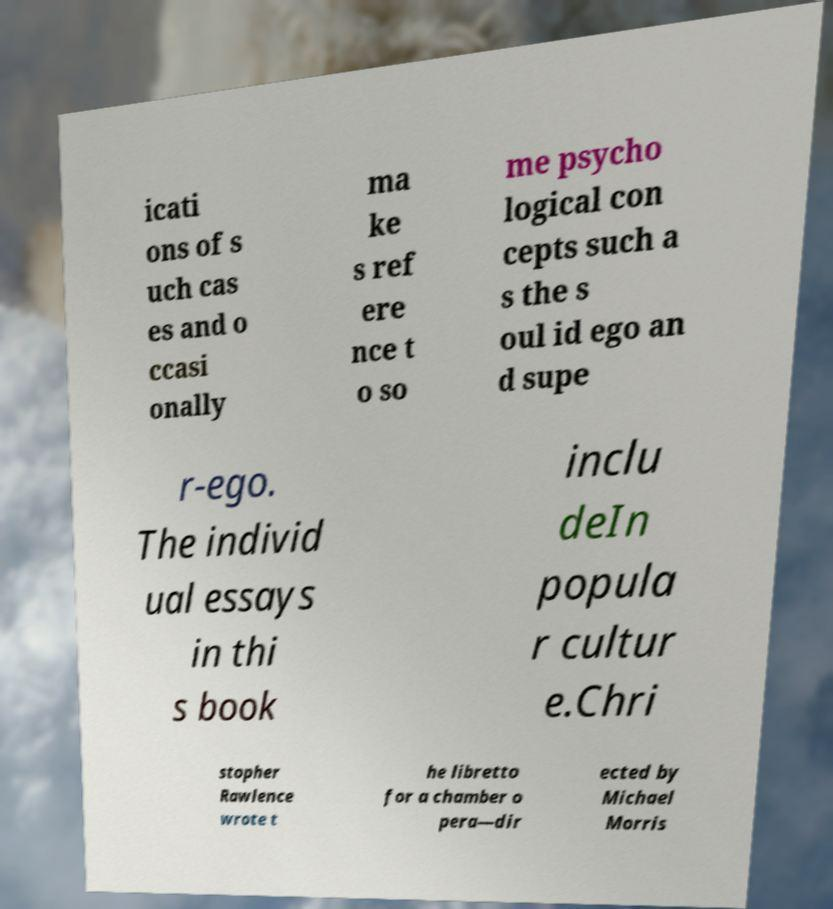Please read and relay the text visible in this image. What does it say? icati ons of s uch cas es and o ccasi onally ma ke s ref ere nce t o so me psycho logical con cepts such a s the s oul id ego an d supe r-ego. The individ ual essays in thi s book inclu deIn popula r cultur e.Chri stopher Rawlence wrote t he libretto for a chamber o pera—dir ected by Michael Morris 